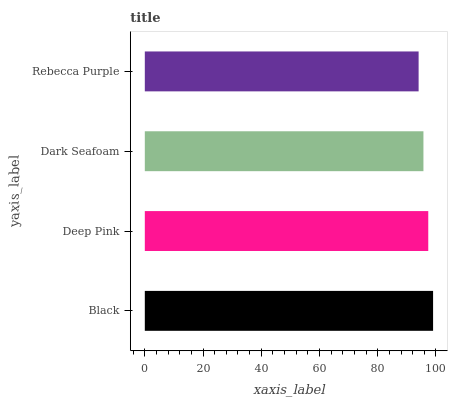Is Rebecca Purple the minimum?
Answer yes or no. Yes. Is Black the maximum?
Answer yes or no. Yes. Is Deep Pink the minimum?
Answer yes or no. No. Is Deep Pink the maximum?
Answer yes or no. No. Is Black greater than Deep Pink?
Answer yes or no. Yes. Is Deep Pink less than Black?
Answer yes or no. Yes. Is Deep Pink greater than Black?
Answer yes or no. No. Is Black less than Deep Pink?
Answer yes or no. No. Is Deep Pink the high median?
Answer yes or no. Yes. Is Dark Seafoam the low median?
Answer yes or no. Yes. Is Dark Seafoam the high median?
Answer yes or no. No. Is Deep Pink the low median?
Answer yes or no. No. 